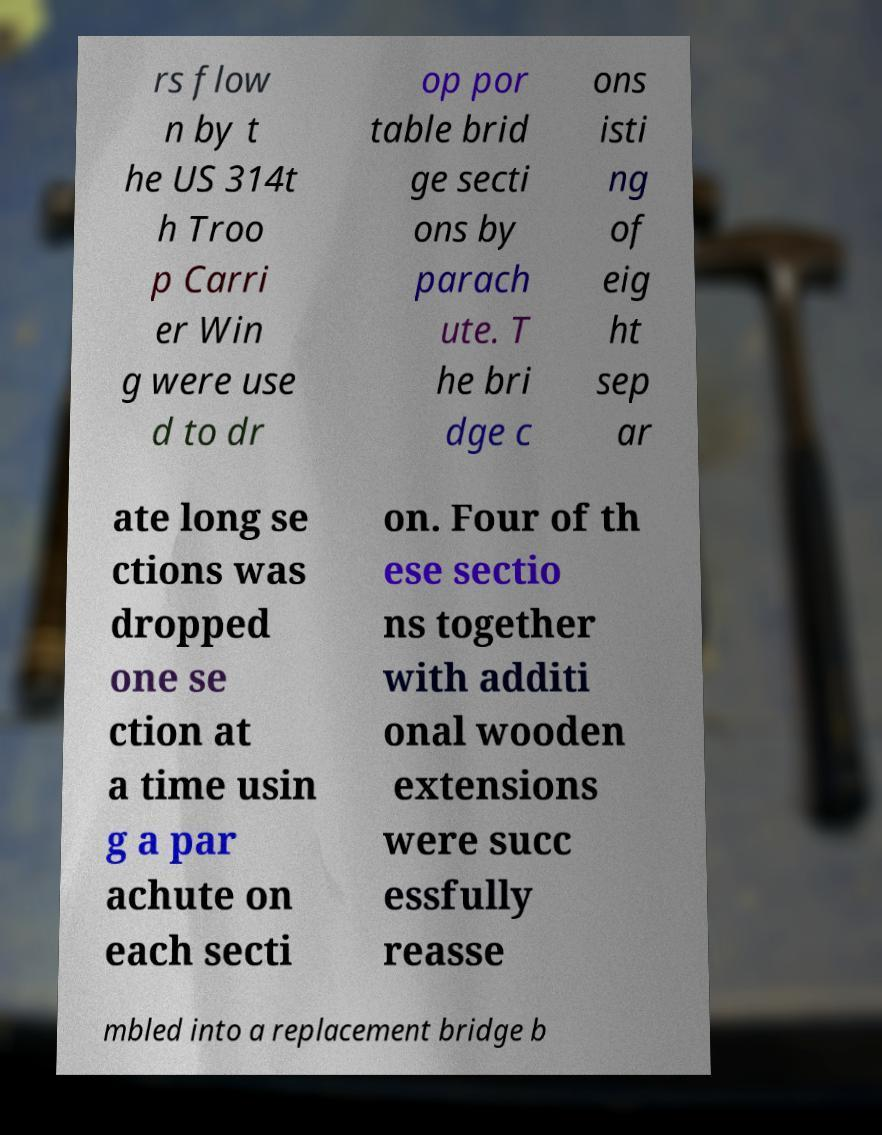Could you extract and type out the text from this image? rs flow n by t he US 314t h Troo p Carri er Win g were use d to dr op por table brid ge secti ons by parach ute. T he bri dge c ons isti ng of eig ht sep ar ate long se ctions was dropped one se ction at a time usin g a par achute on each secti on. Four of th ese sectio ns together with additi onal wooden extensions were succ essfully reasse mbled into a replacement bridge b 